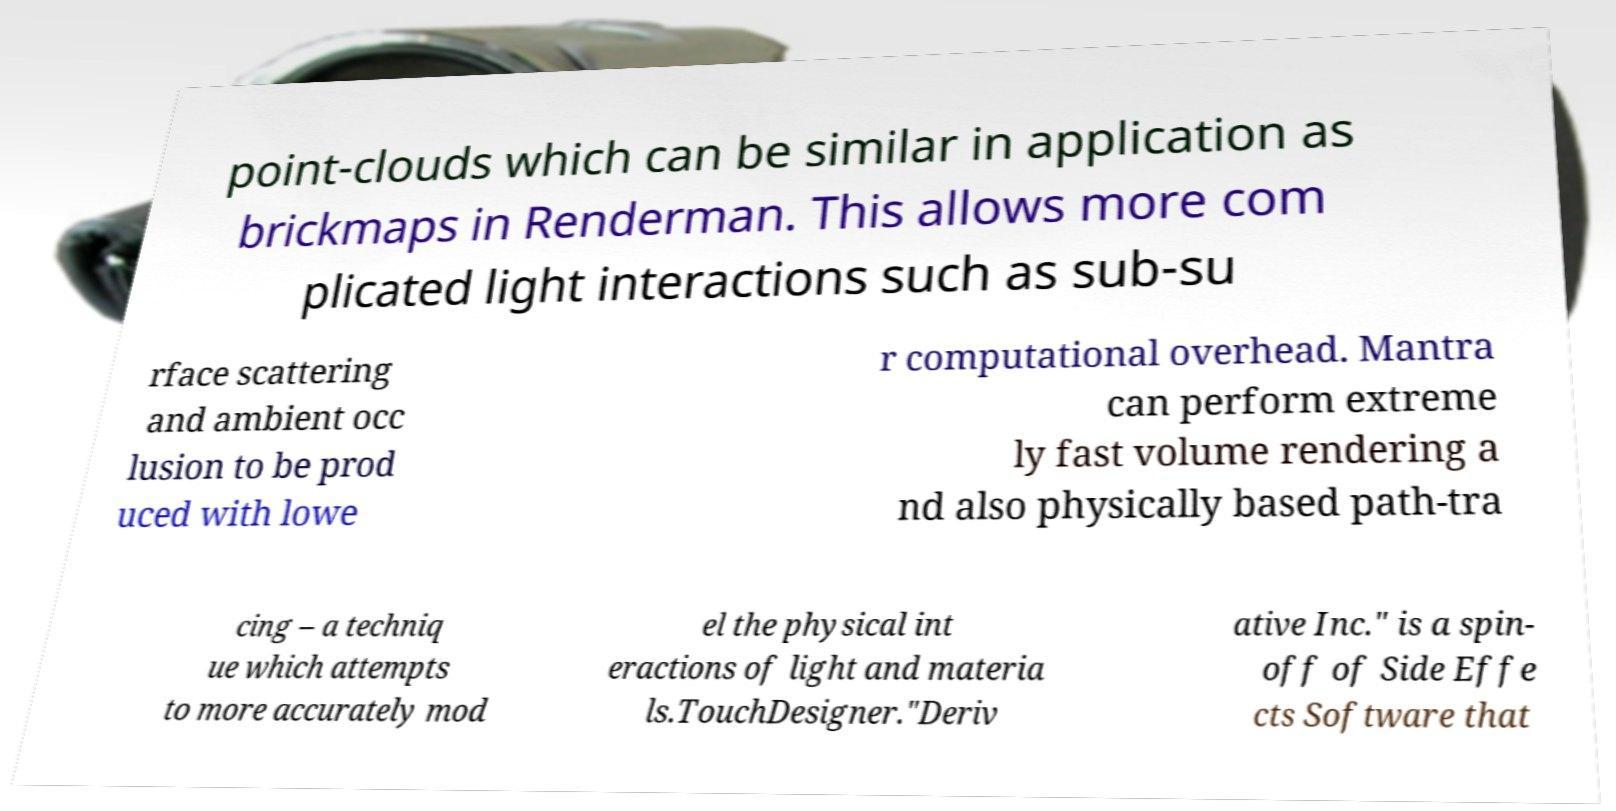Please identify and transcribe the text found in this image. point-clouds which can be similar in application as brickmaps in Renderman. This allows more com plicated light interactions such as sub-su rface scattering and ambient occ lusion to be prod uced with lowe r computational overhead. Mantra can perform extreme ly fast volume rendering a nd also physically based path-tra cing – a techniq ue which attempts to more accurately mod el the physical int eractions of light and materia ls.TouchDesigner."Deriv ative Inc." is a spin- off of Side Effe cts Software that 